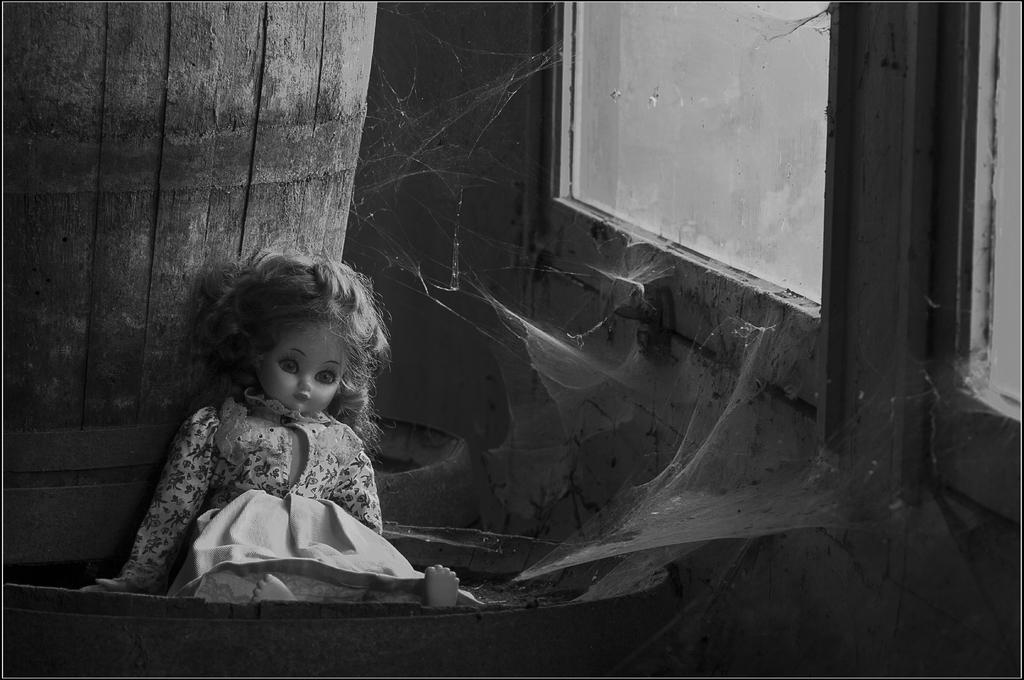What is the color scheme of the image? The image is black and white. What is the doll doing in the image? The doll is sitting on a barrel and leaning against another panel. What objects can be seen in the image besides the doll? There is a glass, a door, and a wall visible in the image. How many yams are being used as a sail for the doll in the image? There are no yams or sails present in the image; it features a doll sitting on a barrel and leaning against another panel. What type of feather can be seen on the doll's hat in the image? There is no hat or feather present on the doll in the image. 